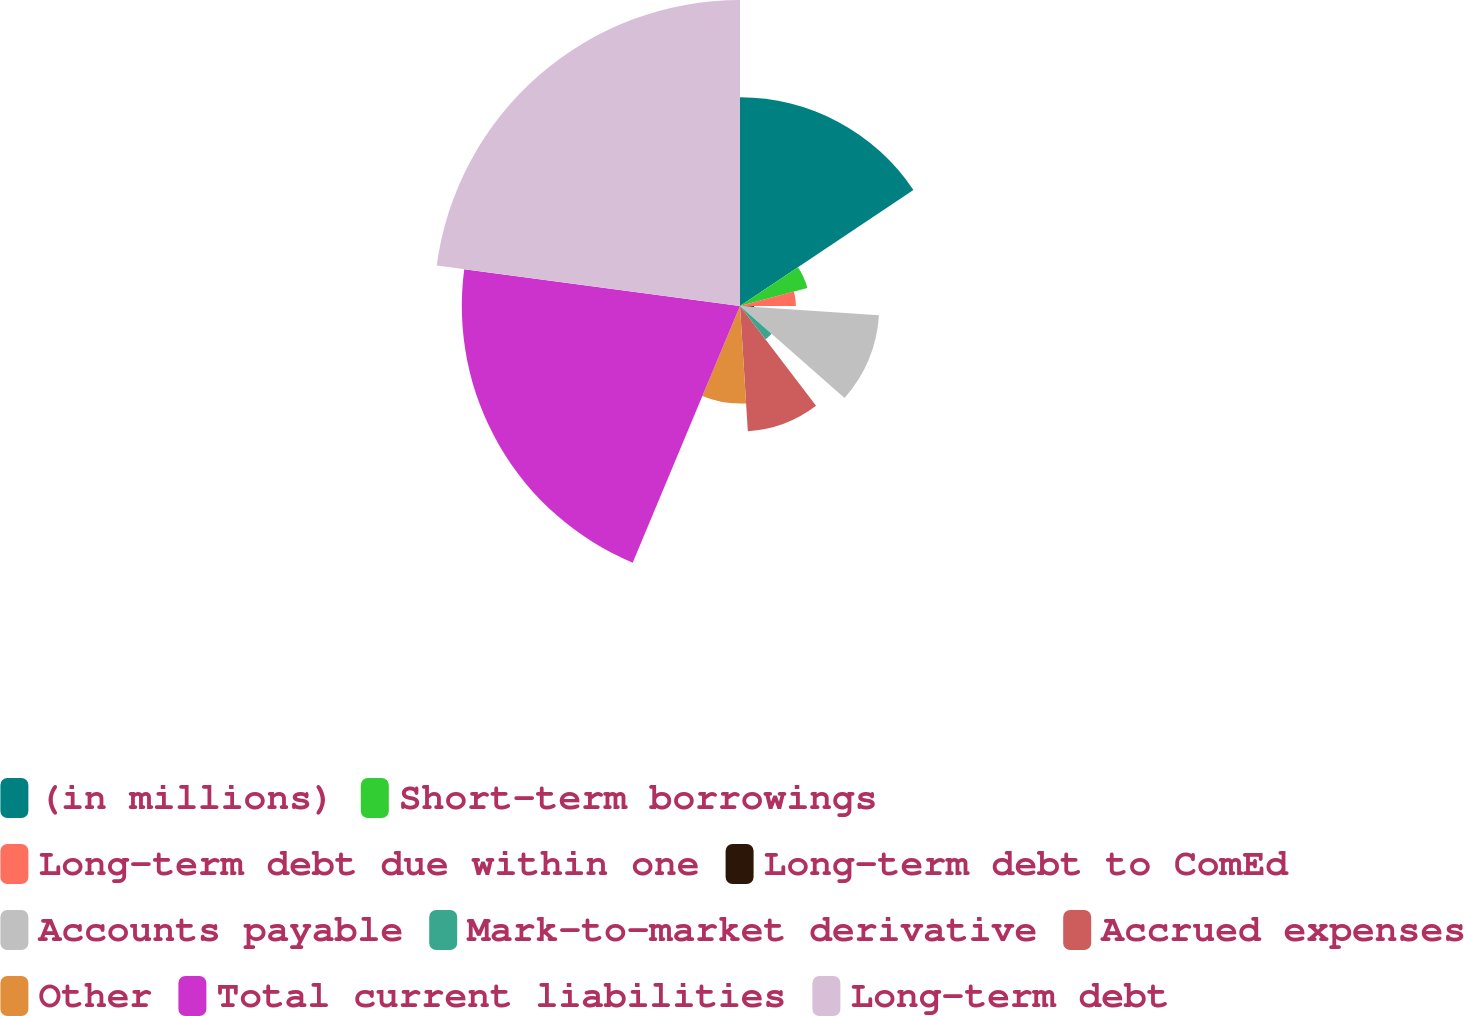Convert chart to OTSL. <chart><loc_0><loc_0><loc_500><loc_500><pie_chart><fcel>(in millions)<fcel>Short-term borrowings<fcel>Long-term debt due within one<fcel>Long-term debt to ComEd<fcel>Accounts payable<fcel>Mark-to-market derivative<fcel>Accrued expenses<fcel>Other<fcel>Total current liabilities<fcel>Long-term debt<nl><fcel>15.61%<fcel>5.22%<fcel>4.18%<fcel>1.06%<fcel>10.42%<fcel>3.14%<fcel>9.38%<fcel>7.3%<fcel>20.81%<fcel>22.89%<nl></chart> 